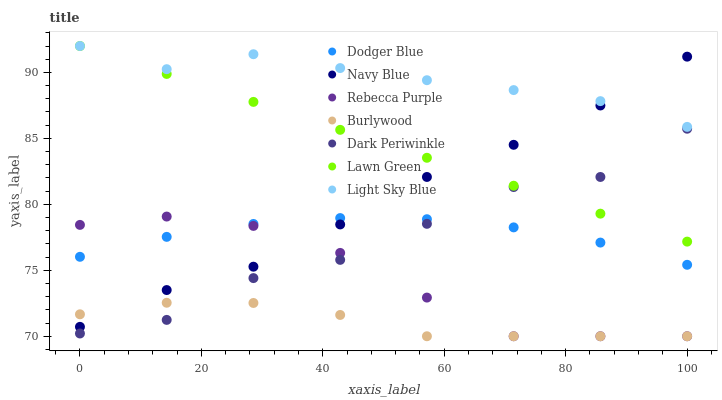Does Burlywood have the minimum area under the curve?
Answer yes or no. Yes. Does Light Sky Blue have the maximum area under the curve?
Answer yes or no. Yes. Does Navy Blue have the minimum area under the curve?
Answer yes or no. No. Does Navy Blue have the maximum area under the curve?
Answer yes or no. No. Is Lawn Green the smoothest?
Answer yes or no. Yes. Is Dark Periwinkle the roughest?
Answer yes or no. Yes. Is Burlywood the smoothest?
Answer yes or no. No. Is Burlywood the roughest?
Answer yes or no. No. Does Burlywood have the lowest value?
Answer yes or no. Yes. Does Navy Blue have the lowest value?
Answer yes or no. No. Does Light Sky Blue have the highest value?
Answer yes or no. Yes. Does Navy Blue have the highest value?
Answer yes or no. No. Is Rebecca Purple less than Lawn Green?
Answer yes or no. Yes. Is Lawn Green greater than Dodger Blue?
Answer yes or no. Yes. Does Navy Blue intersect Rebecca Purple?
Answer yes or no. Yes. Is Navy Blue less than Rebecca Purple?
Answer yes or no. No. Is Navy Blue greater than Rebecca Purple?
Answer yes or no. No. Does Rebecca Purple intersect Lawn Green?
Answer yes or no. No. 